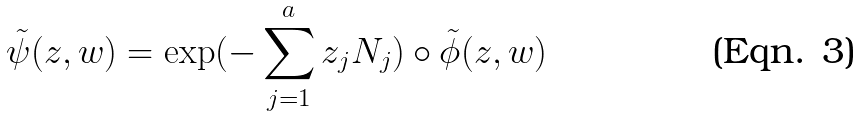<formula> <loc_0><loc_0><loc_500><loc_500>\tilde { \psi } ( { z } , { w } ) = \exp ( - \sum _ { j = 1 } ^ { a } z _ { j } N _ { j } ) \circ \tilde { \phi } ( { z } , { w } )</formula> 